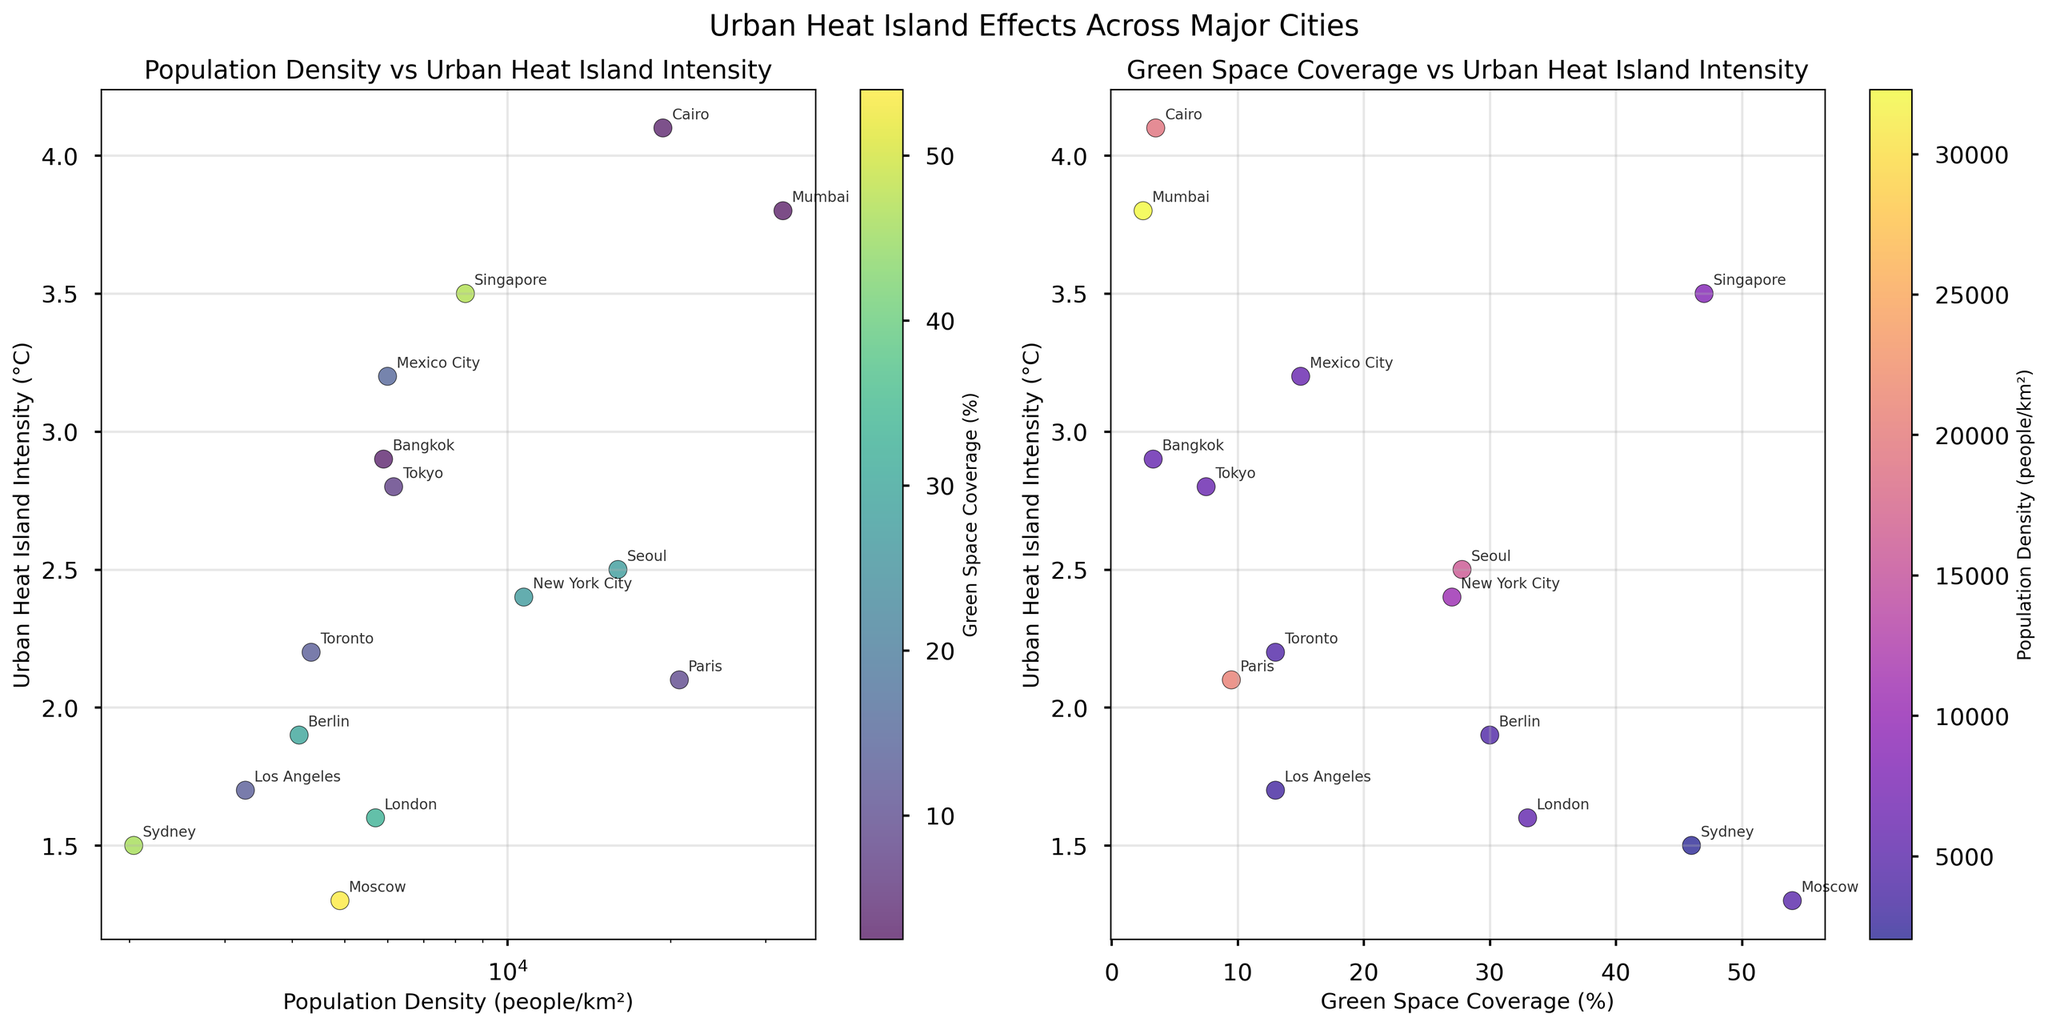What is the population density of the city with the highest Urban Heat Island Intensity (UHI)? To find the city with the highest UHI Intensity, look at the highest point on the y-axis on both scatter plots. According to the UHI Intensities, Cairo has the highest value. Check the x-position of Cairo on the first scatter plot to get the population density.
Answer: 19376 people/km² What title is given to the first scatter plot? The title of the first scatter plot is located at the top of the subplot.
Answer: Population Density vs Urban Heat Island Intensity Which city has the highest Green Space Coverage, and what is its Urban Heat Island Intensity? To find the city with the highest Green Space Coverage, look for the highest point on the x-axis of the second scatter plot. Moscow has the highest Green Space Coverage. Its Urban Heat Island Intensity is shown by the y-coordinate.
Answer: Moscow, 1.3°C How does Urban Heat Island Intensity generally relate to Population Density? Observe the overall trend in the first scatter plot. As Population Density increases, there generally appears to be an increasing trend in Urban Heat Island Intensity.
Answer: UHI generally increases with Population Density Which city has the lowest Urban Heat Island Intensity and what is its Green Space Coverage? To find the city with the lowest UHI, look for the lowest point on the y-axis. According to the subplot, Moscow has the lowest UHI, and its Green Space Coverage is shown by the x-coordinate in the second scatter plot.
Answer: Moscow, 54% Compare the Urban Heat Island Intensities of Tokyo and New York City. Which city has a higher value? Find the positions of Tokyo and New York City on both scatterplots. Tokyo has a higher value than New York City on the y-axis representing UHI Intensity.
Answer: Tokyo What color represents cities with high Green Space Coverage in the first scatter plot? Refer to the color bar on the first subplot that ranges from lower to higher percentages of Green Space Coverage. Darker green colors represent higher Green Space Coverage.
Answer: Darker green Is there a city with both high Green Space Coverage and high Urban Heat Island Intensity? In the second scatter plot, look for points with high x-values (Green Space Coverage) and high y-values (UHI). Singapore has both high Green Space Coverage and a relatively high UHI.
Answer: Singapore What does the color bar on the second scatter plot represent? The label next to the color bar on the second subplot indicates what it represents.
Answer: Population Density (people/km²) How does the Green Space Coverage of Paris compare to that of New York City? Locate Paris and New York City in the second scatter plot and compare their x-coordinates. Paris has a slightly lower Green Space Coverage than New York City.
Answer: Paris has slightly less compared to New York City 